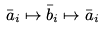<formula> <loc_0><loc_0><loc_500><loc_500>\bar { a } _ { i } \mapsto \bar { b } _ { i } \mapsto \bar { a } _ { i }</formula> 